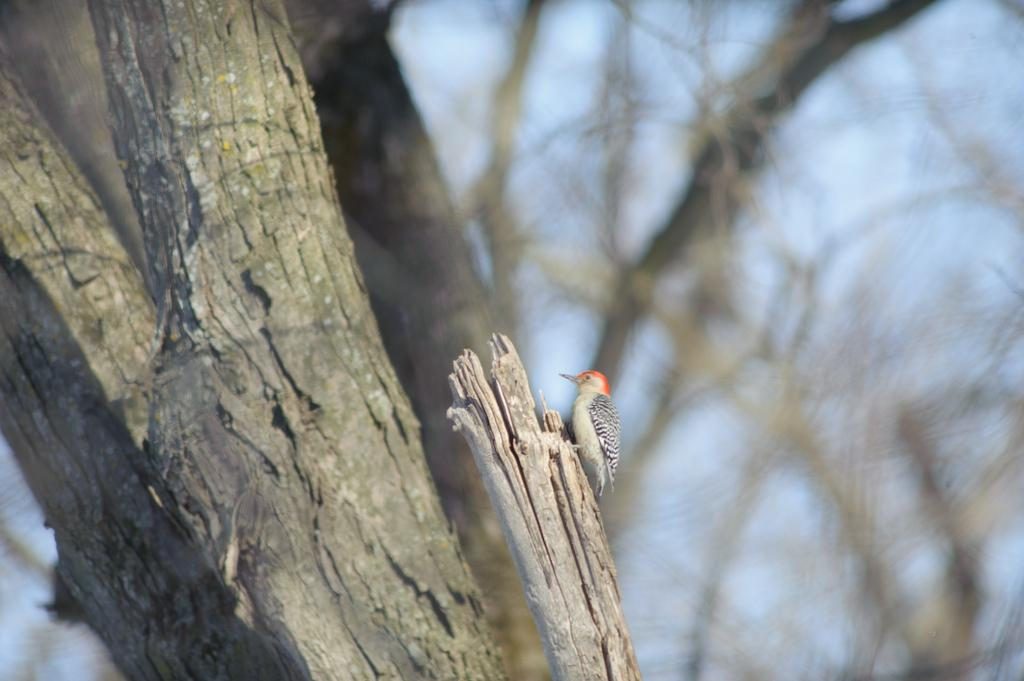What type of animal can be seen in the image? There is a bird in the image. Where is the bird located? The bird is on the bark of a tree. What can be observed about the background of the image? The background of the image is blurred. What part of the natural environment is visible in the image? The sky is visible in the image. What type of coat is the bird wearing in the image? The bird is not wearing a coat in the image; it is a bird and does not wear clothing. 